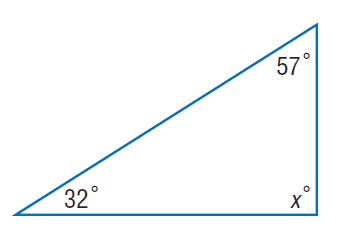Question: Find x.
Choices:
A. 32
B. 57
C. 58
D. 91
Answer with the letter. Answer: D 